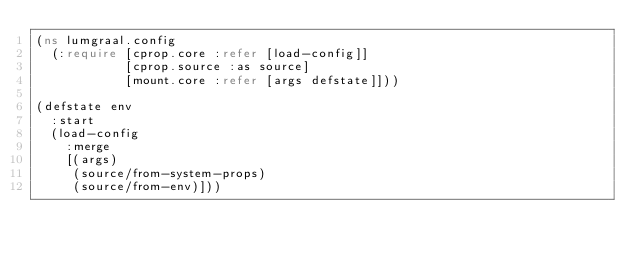Convert code to text. <code><loc_0><loc_0><loc_500><loc_500><_Clojure_>(ns lumgraal.config
  (:require [cprop.core :refer [load-config]]
            [cprop.source :as source]
            [mount.core :refer [args defstate]]))

(defstate env
  :start
  (load-config
    :merge
    [(args)
     (source/from-system-props)
     (source/from-env)]))
</code> 